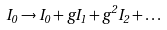Convert formula to latex. <formula><loc_0><loc_0><loc_500><loc_500>I _ { 0 } \rightarrow I _ { 0 } + g I _ { 1 } + g ^ { 2 } I _ { 2 } + \dots</formula> 